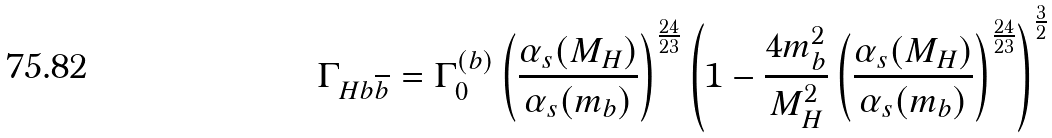<formula> <loc_0><loc_0><loc_500><loc_500>\Gamma _ { H b \overline { b } } = \Gamma _ { 0 } ^ { ( b ) } \left ( \frac { \alpha _ { s } ( M _ { H } ) } { \alpha _ { s } ( m _ { b } ) } \right ) ^ { \frac { 2 4 } { 2 3 } } \left ( 1 - \frac { 4 m _ { b } ^ { 2 } } { M _ { H } ^ { 2 } } \left ( \frac { \alpha _ { s } ( M _ { H } ) } { \alpha _ { s } ( m _ { b } ) } \right ) ^ { \frac { 2 4 } { 2 3 } } \right ) ^ { \frac { 3 } { 2 } }</formula> 